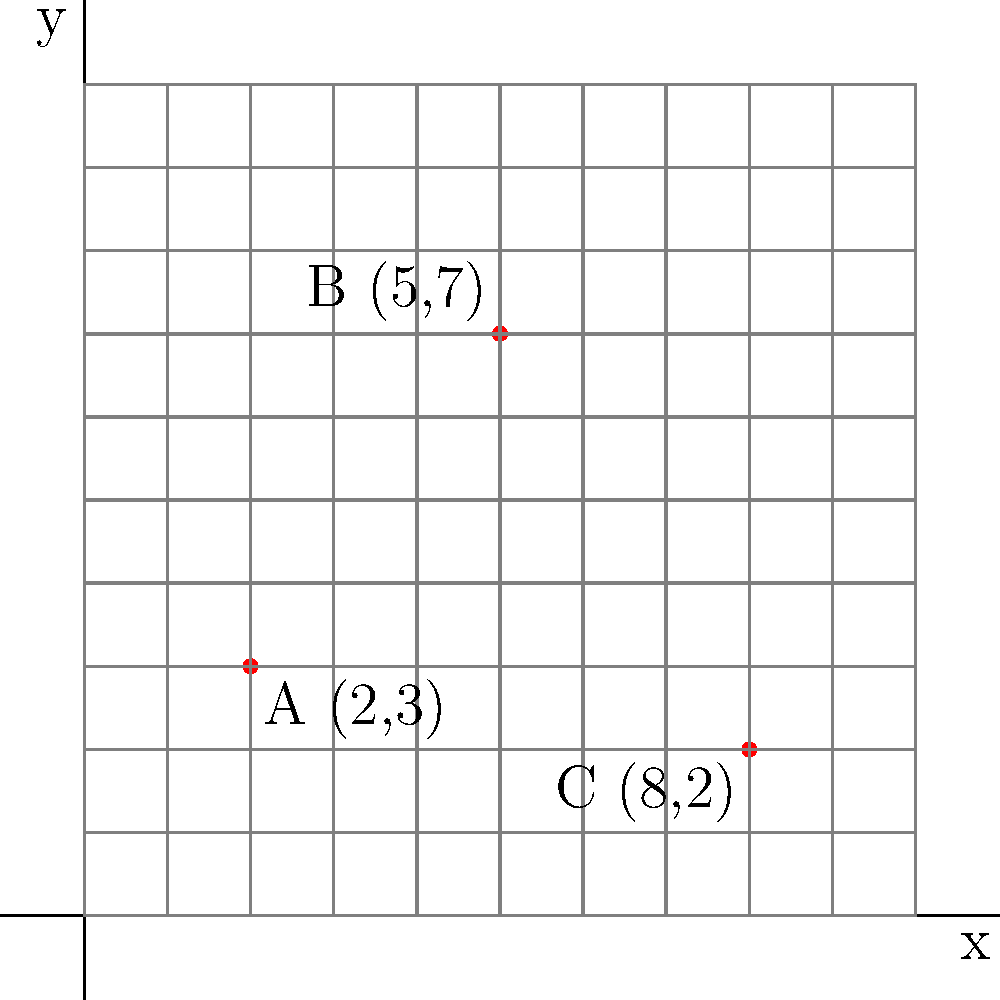A city map shows the locations of three free meal services: A, B, and C. Their coordinates on the map are A(2,3), B(5,7), and C(8,2). If each unit on the map represents one city block, how many blocks apart are the two meal services that are farthest from each other? To find the two meal services that are farthest apart and calculate the distance between them, we need to:

1. Calculate the distances between each pair of points:
   - Distance AB
   - Distance BC
   - Distance AC

2. Use the distance formula: $d = \sqrt{(x_2-x_1)^2 + (y_2-y_1)^2}$

3. For AB:
   $d_{AB} = \sqrt{(5-2)^2 + (7-3)^2} = \sqrt{3^2 + 4^2} = \sqrt{9 + 16} = \sqrt{25} = 5$

4. For BC:
   $d_{BC} = \sqrt{(8-5)^2 + (2-7)^2} = \sqrt{3^2 + (-5)^2} = \sqrt{9 + 25} = \sqrt{34} \approx 5.83$

5. For AC:
   $d_{AC} = \sqrt{(8-2)^2 + (2-3)^2} = \sqrt{6^2 + (-1)^2} = \sqrt{36 + 1} = \sqrt{37} \approx 6.08$

6. The largest distance is between A and C, approximately 6.08 blocks.

7. Since we're counting city blocks, we need to round up to the nearest whole number.

Therefore, the two meal services that are farthest apart are A and C, and they are 7 blocks away from each other.
Answer: 7 blocks 